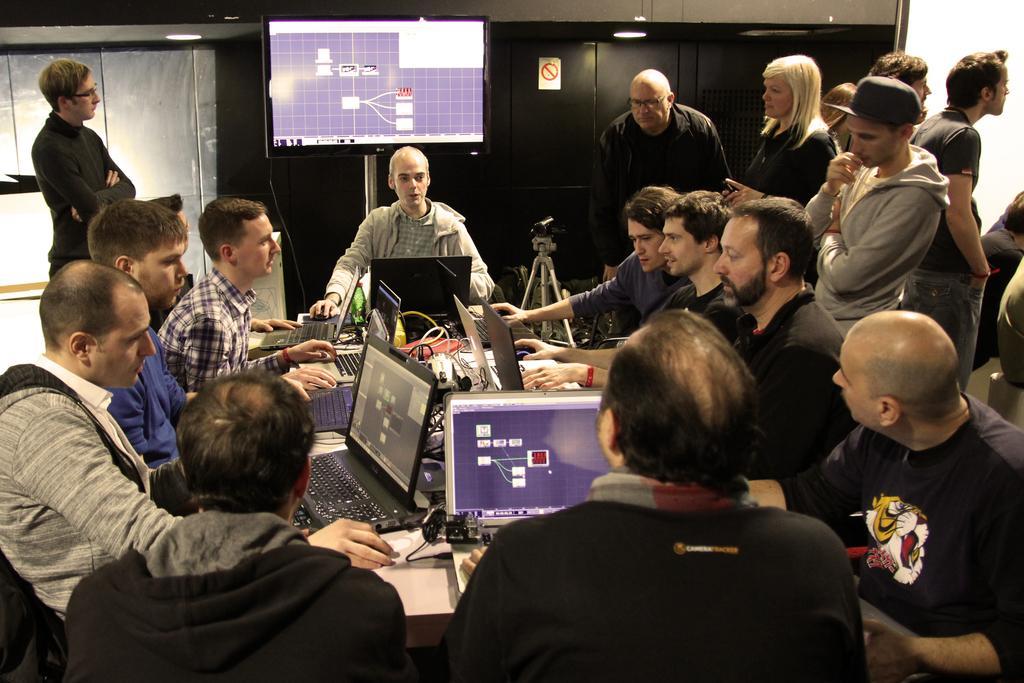In one or two sentences, can you explain what this image depicts? I can see a group of people, Who are standing and sitting in chairs, laptops, after that i can see a camera next i can see a television, few cupboards, lights. 